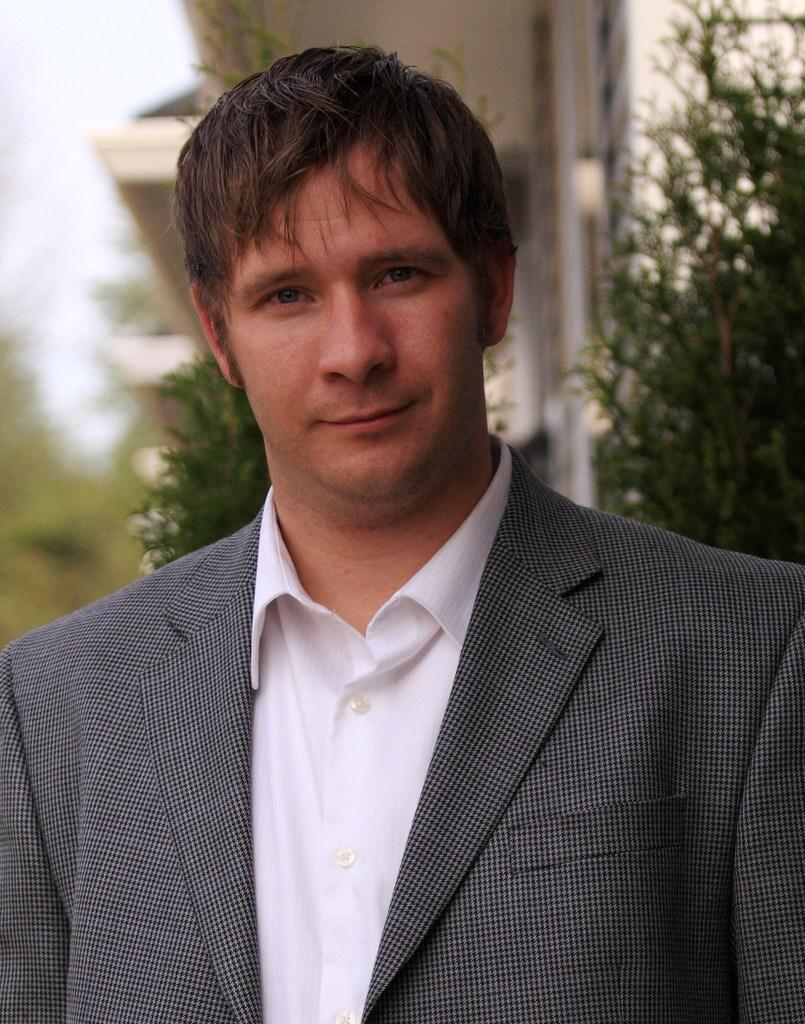What is the person in the image wearing? The person in the image is wearing a suit. What is the person doing in the image? The person is watching something. What type of natural elements can be seen in the image? There are trees and plants in the image. What type of man-made structure is visible in the image? There is a building in the image. What part of the natural environment is visible in the image? The sky is visible in the image. What type of popcorn is the person eating while watching in the image? There is no popcorn present in the image, and the person is not eating anything. 